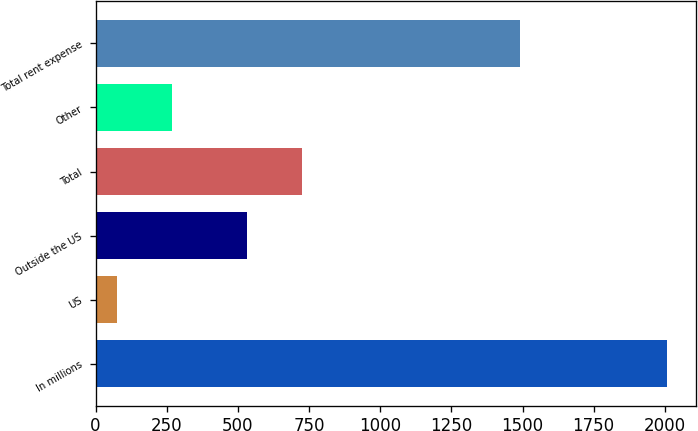Convert chart. <chart><loc_0><loc_0><loc_500><loc_500><bar_chart><fcel>In millions<fcel>US<fcel>Outside the US<fcel>Total<fcel>Other<fcel>Total rent expense<nl><fcel>2008<fcel>73.7<fcel>532<fcel>725.43<fcel>267.13<fcel>1491.6<nl></chart> 